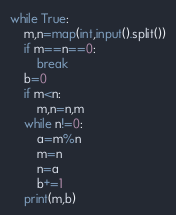Convert code to text. <code><loc_0><loc_0><loc_500><loc_500><_Python_>while True:
    m,n=map(int,input().split())
    if m==n==0:
        break
    b=0
    if m<n:
        m,n=n,m
    while n!=0:    
        a=m%n
        m=n
        n=a
        b+=1
    print(m,b)
</code> 